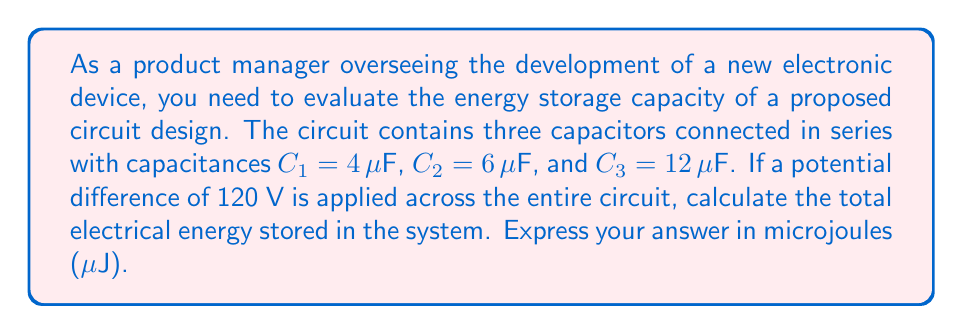Solve this math problem. To solve this problem, we'll follow these steps:

1) First, we need to calculate the equivalent capacitance ($C_{eq}$) of the series circuit:

   $$\frac{1}{C_{eq}} = \frac{1}{C_1} + \frac{1}{C_2} + \frac{1}{C_3}$$
   $$\frac{1}{C_{eq}} = \frac{1}{4} + \frac{1}{6} + \frac{1}{12} = \frac{3}{12} + \frac{2}{12} + \frac{1}{12} = \frac{6}{12} = \frac{1}{2}$$
   $$C_{eq} = 2 \mu F$$

2) Now that we have the equivalent capacitance, we can use the formula for energy stored in a capacitor:

   $$E = \frac{1}{2}CV^2$$

   Where:
   $E$ is the energy stored
   $C$ is the capacitance
   $V$ is the voltage across the capacitor

3) Substituting our values:

   $$E = \frac{1}{2} \cdot (2 \times 10^{-6} F) \cdot (120 V)^2$$

4) Calculating:

   $$E = \frac{1}{2} \cdot (2 \times 10^{-6}) \cdot (14400)$$
   $$E = 14400 \times 10^{-6} J = 14400 \mu J$$

Therefore, the total electrical energy stored in the system is 14400 μJ.
Answer: 14400 μJ 